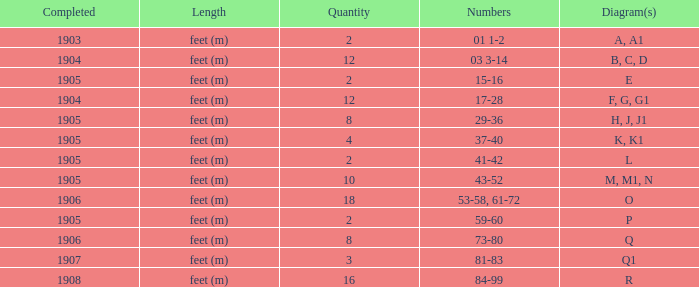What are the numbers for the item completed earlier than 1904? 01 1-2. 